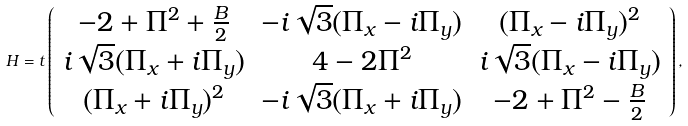Convert formula to latex. <formula><loc_0><loc_0><loc_500><loc_500>H = t \left ( \begin{array} { c c c } - 2 + \Pi ^ { 2 } + \frac { B } { 2 } & - i \sqrt { 3 } ( \Pi _ { x } - i \Pi _ { y } ) & ( \Pi _ { x } - i \Pi _ { y } ) ^ { 2 } \\ i \sqrt { 3 } ( \Pi _ { x } + i \Pi _ { y } ) & 4 - 2 \Pi ^ { 2 } & i \sqrt { 3 } ( \Pi _ { x } - i \Pi _ { y } ) \\ ( \Pi _ { x } + i \Pi _ { y } ) ^ { 2 } & - i \sqrt { 3 } ( \Pi _ { x } + i \Pi _ { y } ) & - 2 + \Pi ^ { 2 } - \frac { B } { 2 } \\ \end{array} \right ) ,</formula> 